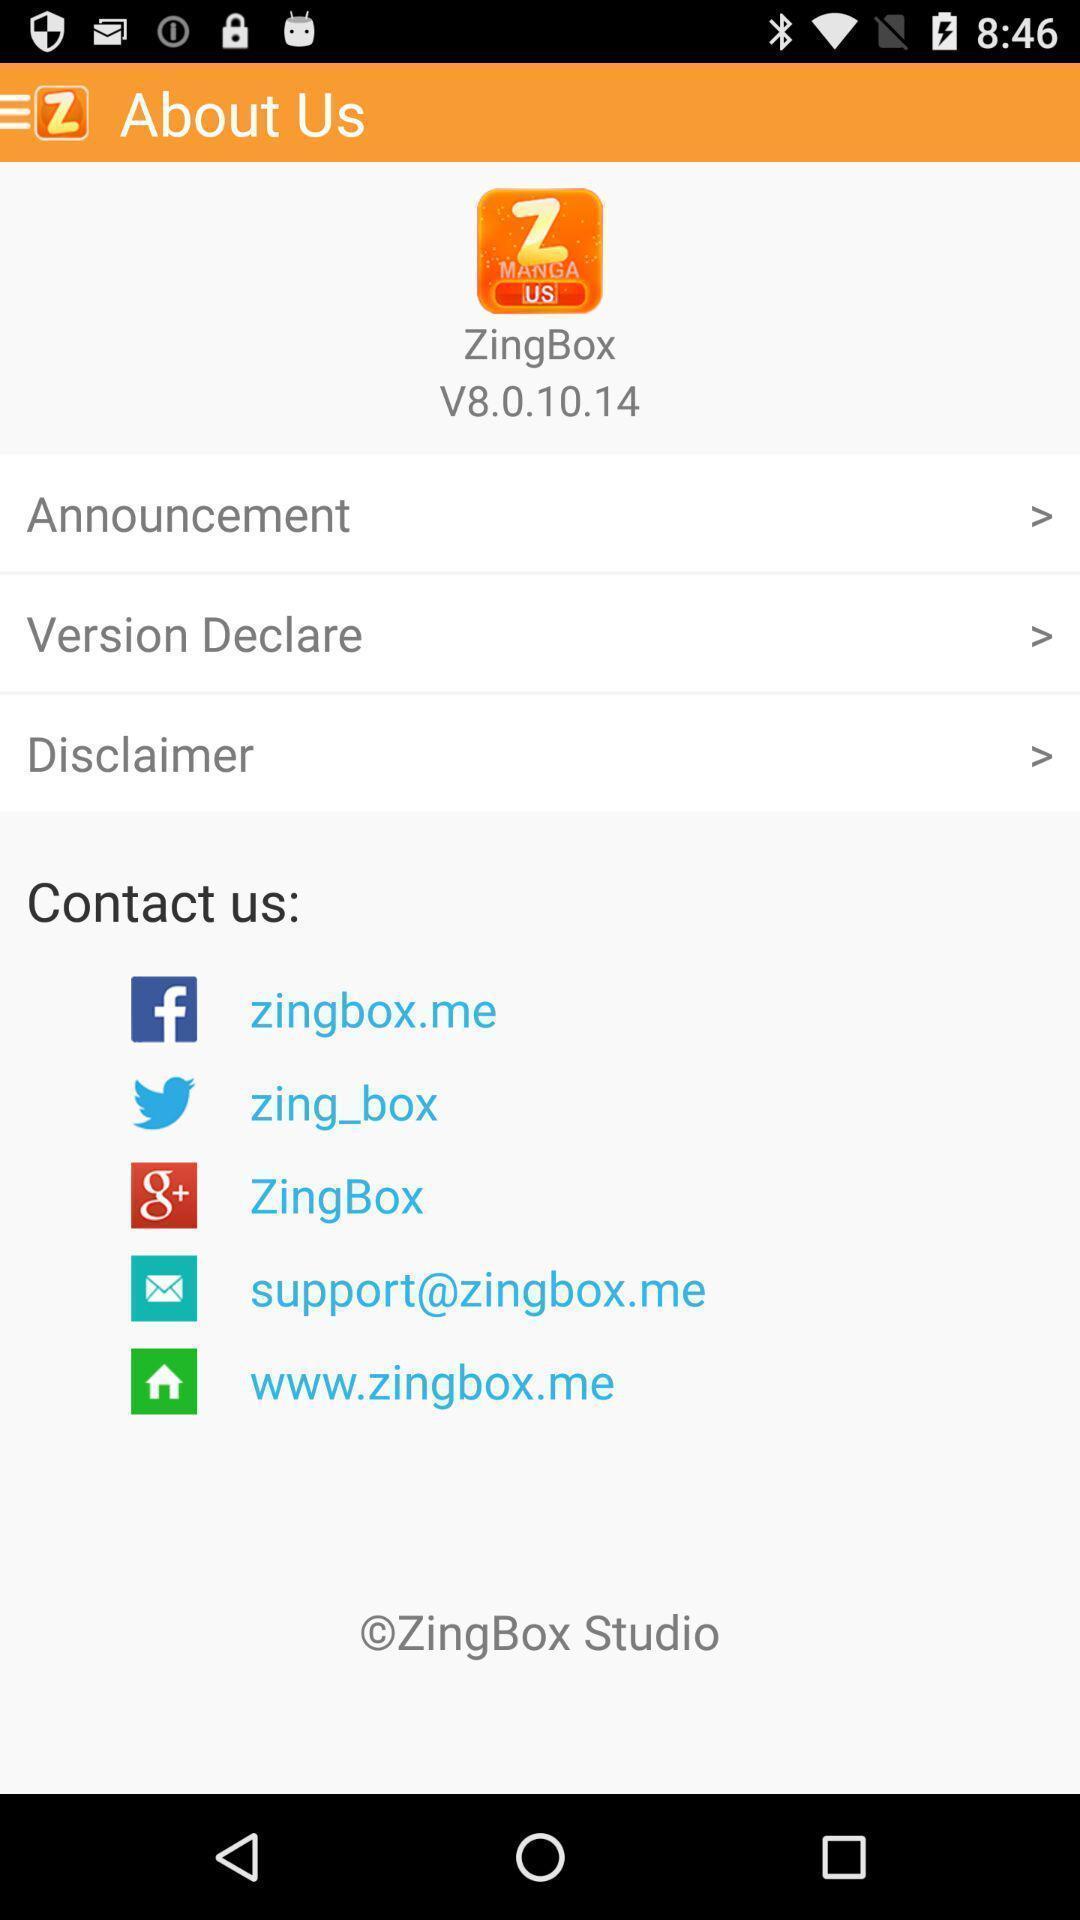Tell me what you see in this picture. Page showing different information. 